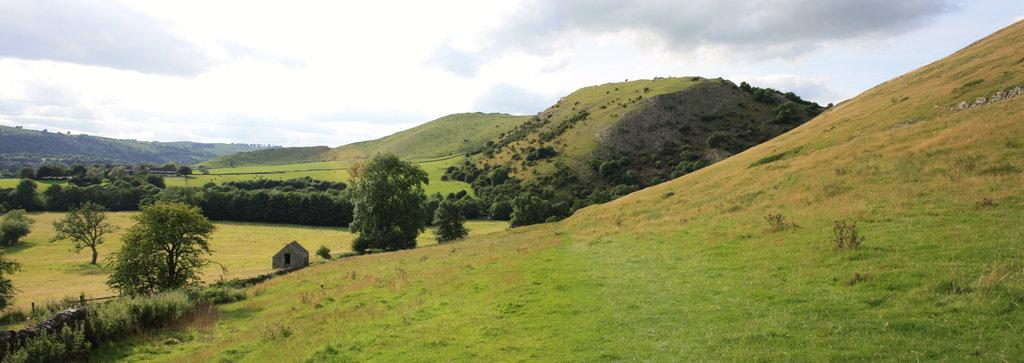What type of landscape feature is on the right side of the image? There are hills on the right side of the image. What is located at the bottom of the image? There are plants at the bottom of the image. What structure is in the middle of the image? There is a small house in the middle of the image. What is visible at the top of the image? The sky is visible at the top of the image. How many clocks can be seen hanging on the walls of the small house in the image? There is no information about clocks in the image, as it only mentions the presence of hills, plants, a small house, and the sky. 